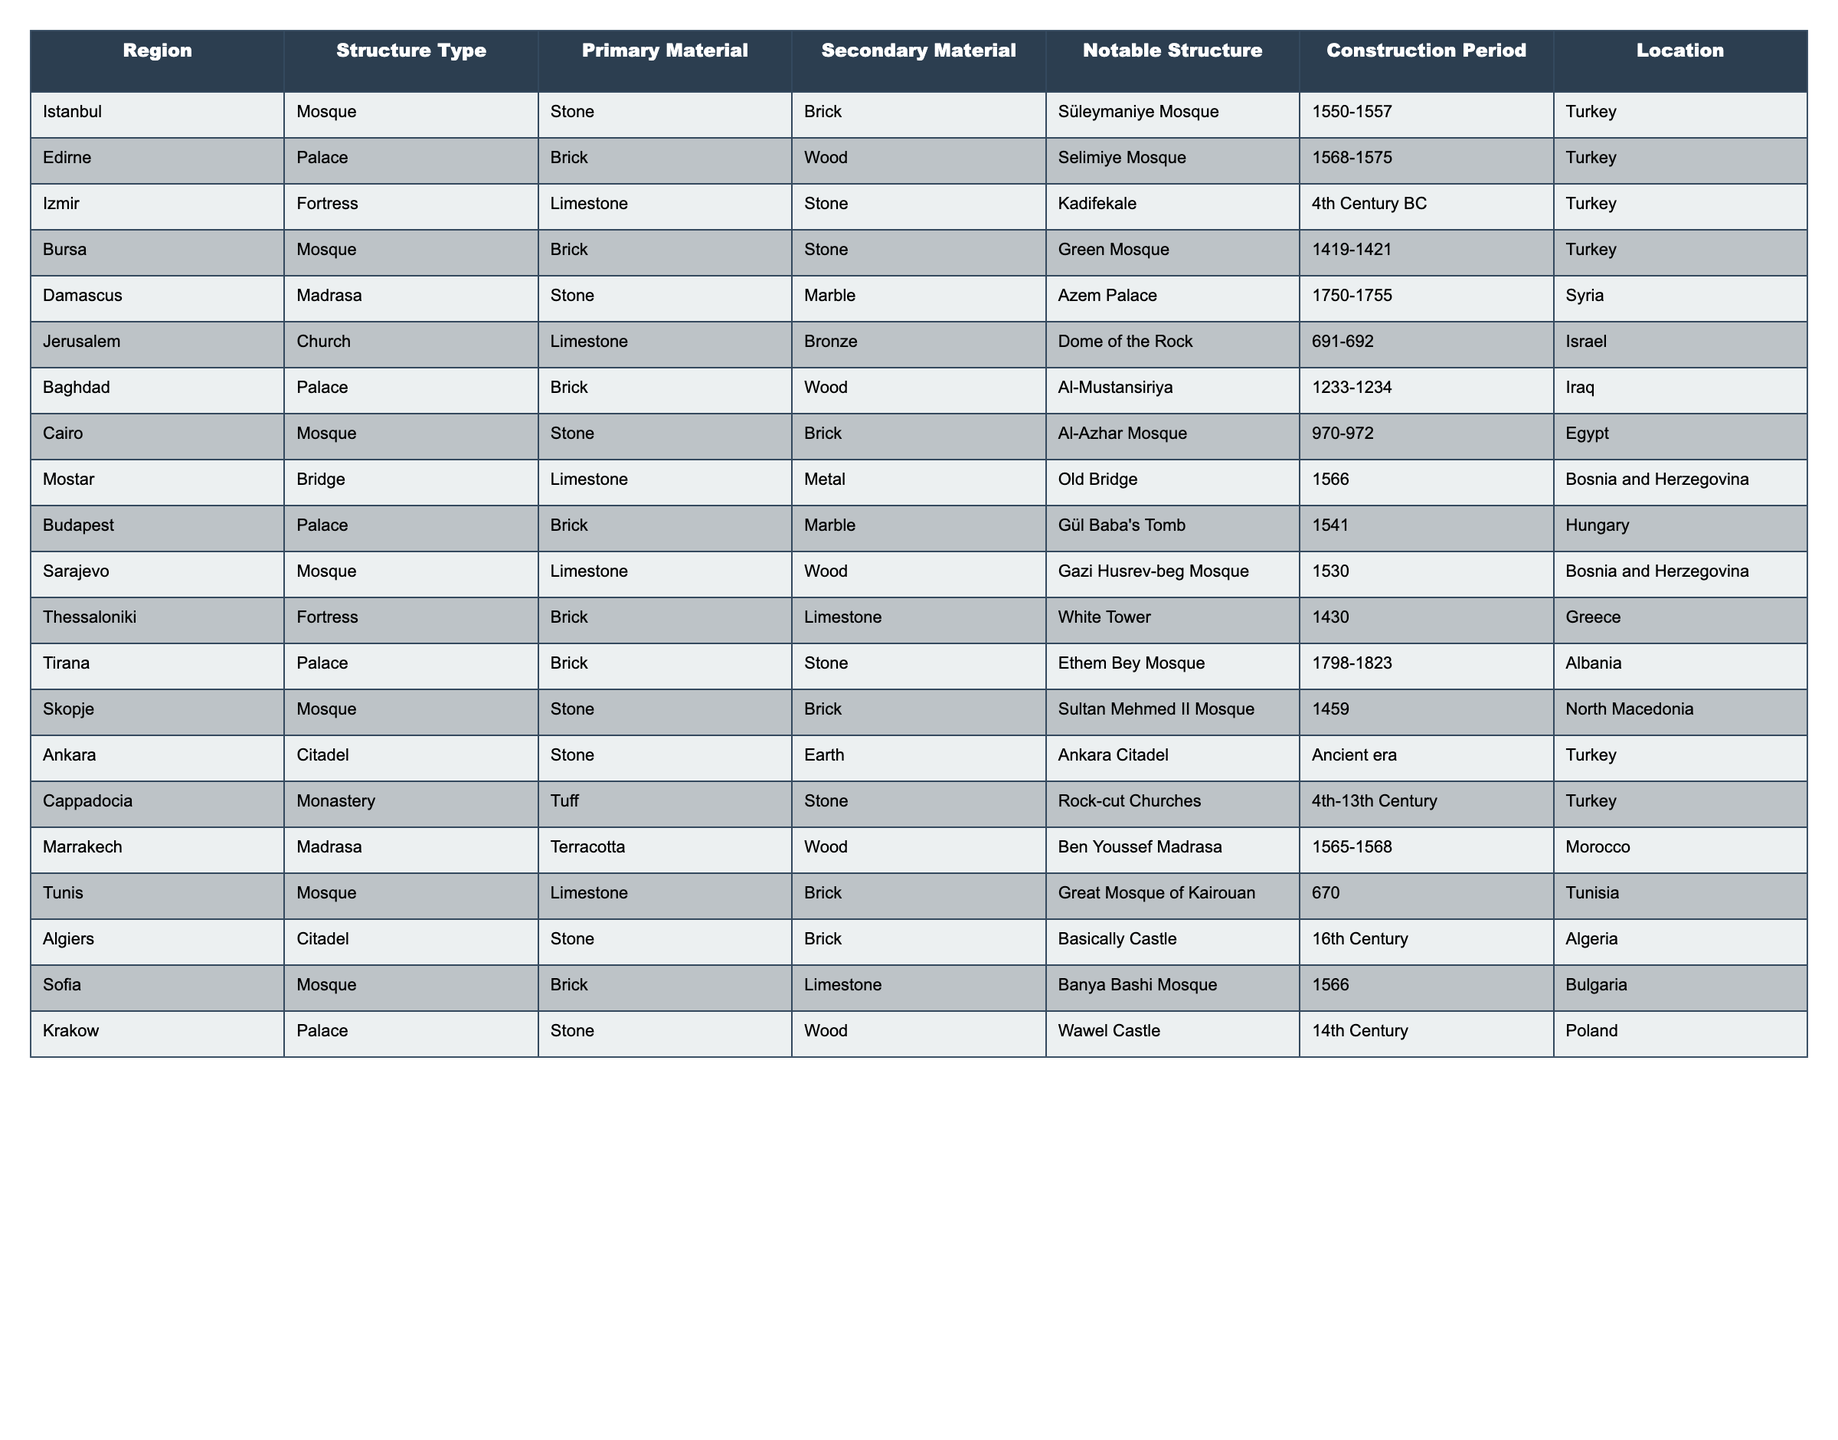What is the primary construction material used in the Süleymaniye Mosque? The table indicates that the primary construction material for the Süleymaniye Mosque is stone, as listed under the "Primary Material" column for that particular structure.
Answer: Stone Which region has a fortress made primarily of limestone? The table shows that in Izmir, a fortress called Kadifekale is made primarily of limestone, as noted in the "Primary Material" column for that region and structure type.
Answer: Izmir What is the notable structure built in Edirne? Referring to the table, the notable structure built in Edirne is the Selimiye Mosque, which is mentioned explicitly in the "Notable Structure" column for that region and structure type.
Answer: Selimiye Mosque Are there any structures built in Baghdad using stone as the primary material? Looking at the table, Baghdad's notable structure, Al-Mustansiriya, uses brick as the primary material; therefore, no structures in Baghdad are reported to use stone as the primary material.
Answer: No What is the secondary material used in the construction of the Old Bridge in Mostar? The table notes that the Old Bridge, located in Mostar, has metal as its secondary material, which is provided in the "Secondary Material" column for that structure type.
Answer: Metal How many mosques use brick as their primary construction material? By reviewing the table, we identify the mosques: Green Mosque, Al-Azhar Mosque, Gazi Husrev-beg Mosque, and Banya Bashi Mosque, which totals to four mosques using brick as their primary material.
Answer: 4 Which structure type in Jerusalem uses limestone as the primary material? The table indicates that the Dome of the Rock in Jerusalem is classified as a church, which uses limestone as its primary material.
Answer: Church Are there more palaces or mosques documented in the table? The data shows there are six mosques (Süleymaniye, Green Mosque, Al-Azhar Mosque, Gazi Husrev-beg Mosque, Ethem Bey Mosque, and Banya Bashi Mosque) and seven palaces (Selimiye Mosque, Al-Mustansiriya, Gül Baba's Tomb, and more). Therefore, there are more palaces.
Answer: Palaces What is the period of construction for the Great Mosque of Kairouan? The table indicates that the Great Mosque of Kairouan was constructed in the year 670, which is noted in the "Construction Period" column for that mosque.
Answer: 670 In which region is the Green Mosque located, and what is its construction period? The Green Mosque is located in Bursa, and its construction period is from 1419 to 1421; both details can be found directly in the corresponding columns of the table.
Answer: Bursa, 1419-1421 